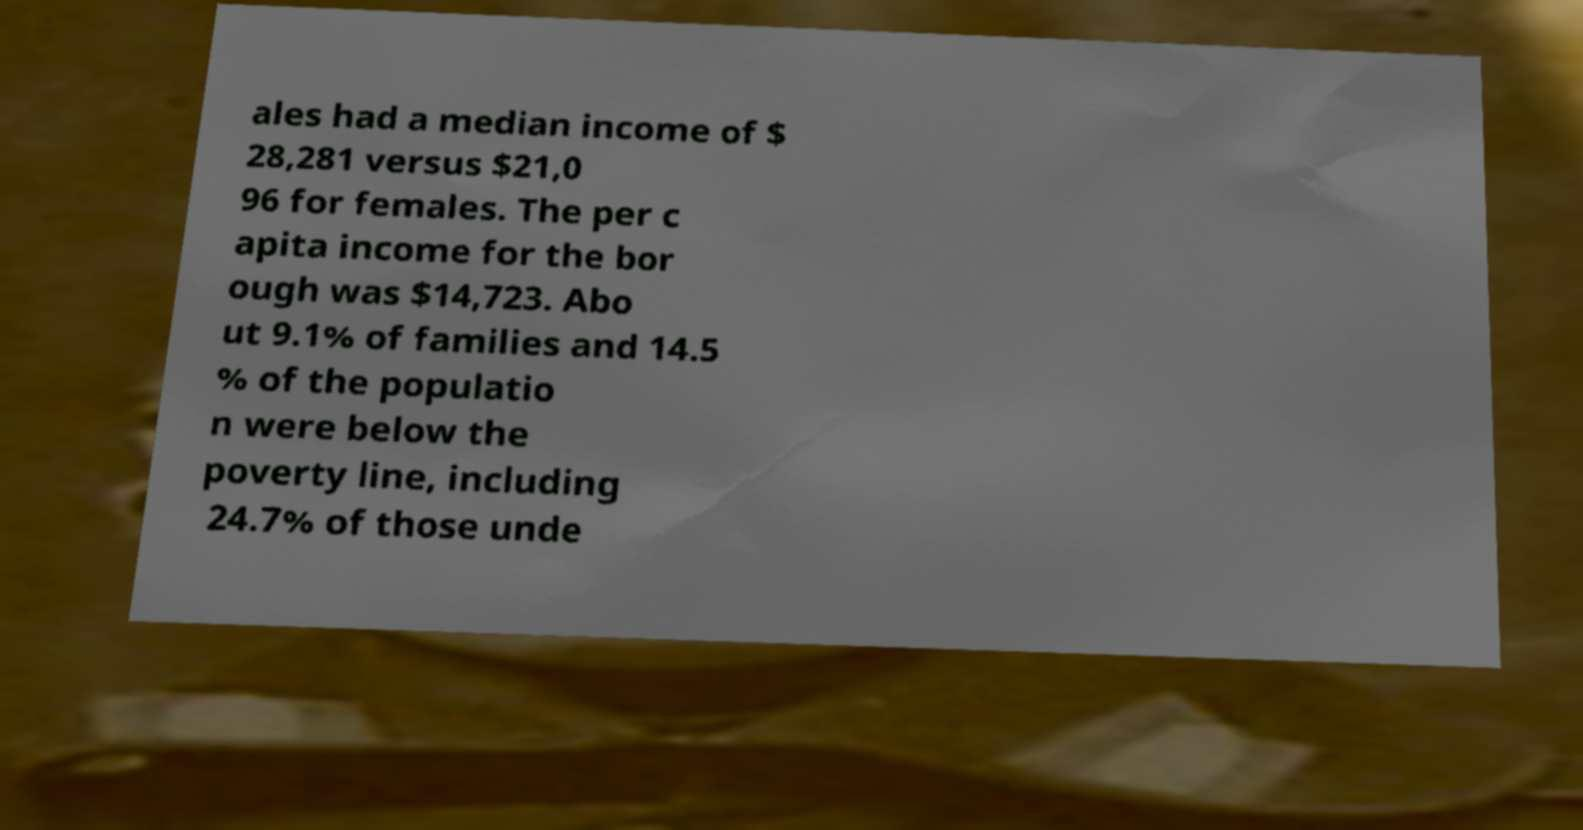Please read and relay the text visible in this image. What does it say? ales had a median income of $ 28,281 versus $21,0 96 for females. The per c apita income for the bor ough was $14,723. Abo ut 9.1% of families and 14.5 % of the populatio n were below the poverty line, including 24.7% of those unde 